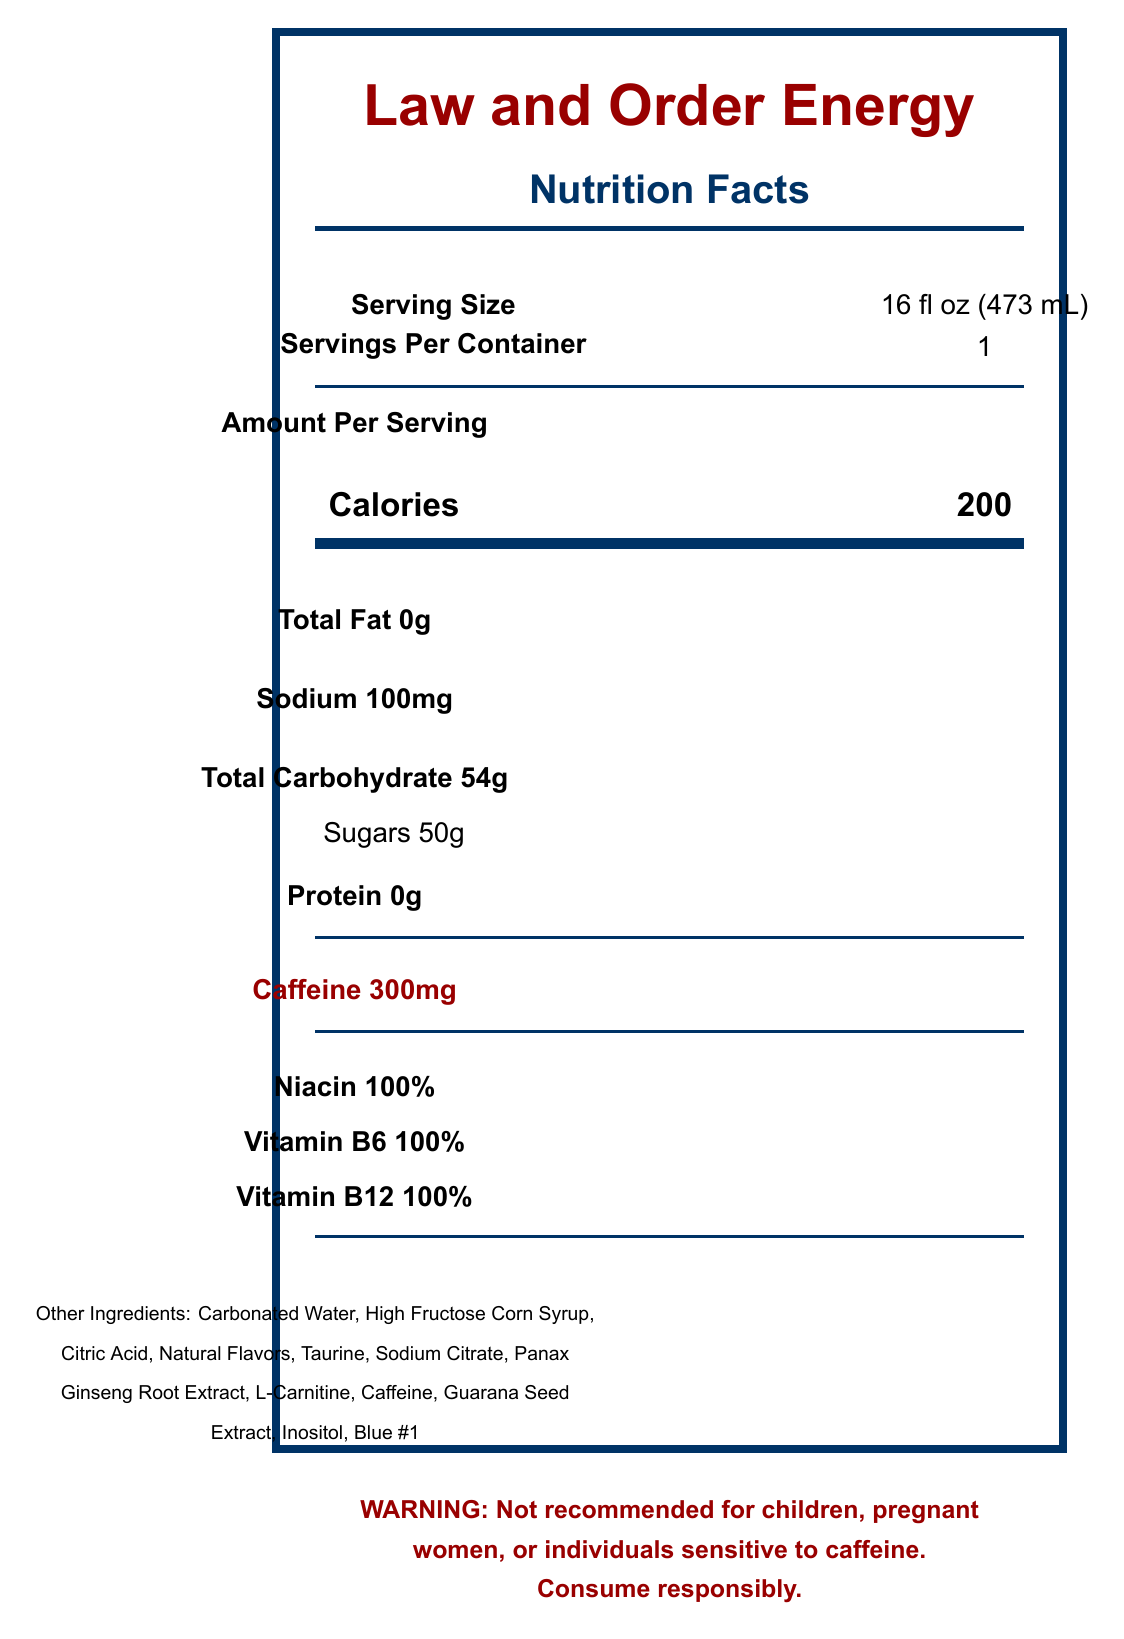what is the serving size? The serving size is explicitly stated in the nutrition facts section of the document.
Answer: 16 fl oz (473 mL) how many servings are in one container? The document specifies that there is one serving per container.
Answer: 1 how many calories are in one serving? The document states in the nutrition facts that a serving contains 200 calories.
Answer: 200 what is the total carbohydrate content per serving? According to the document, the total carbohydrate content per serving is 54g.
Answer: 54g List three vitamins included in the drink and their amounts. The vitamins and their amounts are explicitly listed in the document.
Answer: Niacin 100%, Vitamin B6 100%, Vitamin B12 100% how much sugar does one serving contain? The nutrition facts section indicates that there are 50g of sugar per serving.
Answer: 50g what is the caffeine content per serving? The document clearly states that each serving contains 300mg of caffeine.
Answer: 300mg Is the product suitable for children or pregnant women? The warning section explicitly states that the product is not recommended for children or pregnant women.
Answer: No What are the primary marketing claims for this product? These marketing claims are listed in the marketing claims section of the document.
Answer: Supports alertness and focus for long shifts; Provides energy to uphold the law 24/7; Zero tolerance for drowsiness based on the document, what kind of energy does the drink aim to provide? The marketing claims of the document indicate that the drink supports alertness and focus and offers energy suited for long, demanding periods of work.
Answer: It aims to support alertness and focus for long shifts and provide energy to uphold the law 24/7. What should individuals sensitive to caffeine do? The warning section states that individuals sensitive to caffeine should consume it responsibly.
Answer: Consume responsibly or avoid it. Which ingredient is NOT present in the drink? A. High Fructose Corn Syrup B. Aspartame C. Panax Ginseng Root Extract D. Taurine The list of ingredients does not include Aspartame.
Answer: B. Aspartame examine the document and select the correct statement: I. The drink is low in calories II. The drink has a high caffeine content III. The drink provides 100% of the daily value of Vitamin C The document shows that the caffeine content is 300mg, indicating it has a high caffeine content.
Answer: II. The drink has a high caffeine content does the document specify the amount of Taurine per serving? The document lists Taurine as an ingredient but does not specify the amount per serving.
Answer: No Summarize the main idea of the document. This summary encapsulates the core details about the nutritional content, intended benefits, and warnings associated with consuming the energy drink as provided in the document.
Answer: The document details the Nutrition Facts for "Law and Order Energy" drink, emphasizing its high caffeine content (300mg per serving), calories (200 per serving), ingredients, vitamins (100% daily value of Niacin, Vitamin B6, and Vitamin B12), marketing claims about enhancing focus and energy for demanding shifts, and warnings against consumption by children, pregnant women, or those sensitive to caffeine. does the drink contain natural flavors? The list of ingredients specifies "Natural Flavors" as one of the components.
Answer: Yes How does the product relate to law enforcement? The slogan "Keeping the streets safe, one sip at a time!" and marketing claims about maintaining alertness for law enforcement are key ties to law enforcement.
Answer: The marketing claims suggest that the drink is designed to support focus and energy required for law enforcement, indicated by the marketing claims and slogan. 